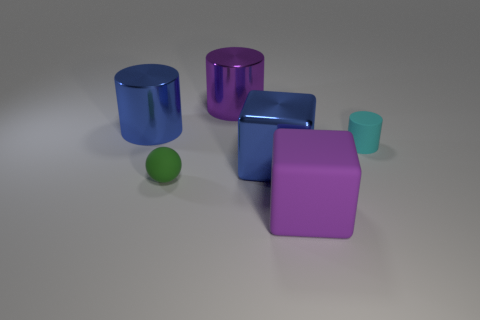There is a tiny thing that is behind the blue metal cube; are there any purple things that are behind it?
Your response must be concise. Yes. How many other objects are there of the same shape as the tiny cyan matte thing?
Your answer should be very brief. 2. Do the purple rubber thing and the cyan matte thing have the same shape?
Keep it short and to the point. No. What is the color of the rubber thing that is both in front of the cyan matte cylinder and to the right of the green rubber thing?
Ensure brevity in your answer.  Purple. How many big objects are either blue objects or purple metal cylinders?
Your answer should be very brief. 3. Is there anything else that is the same color as the sphere?
Offer a very short reply. No. What material is the tiny thing that is behind the small matte object that is in front of the cylinder that is to the right of the big purple block?
Ensure brevity in your answer.  Rubber. How many metal things are either large purple things or large blue things?
Provide a short and direct response. 3. What number of cyan things are either small rubber spheres or small rubber objects?
Provide a short and direct response. 1. Is the color of the large object that is on the left side of the large purple cylinder the same as the metallic block?
Your response must be concise. Yes. 